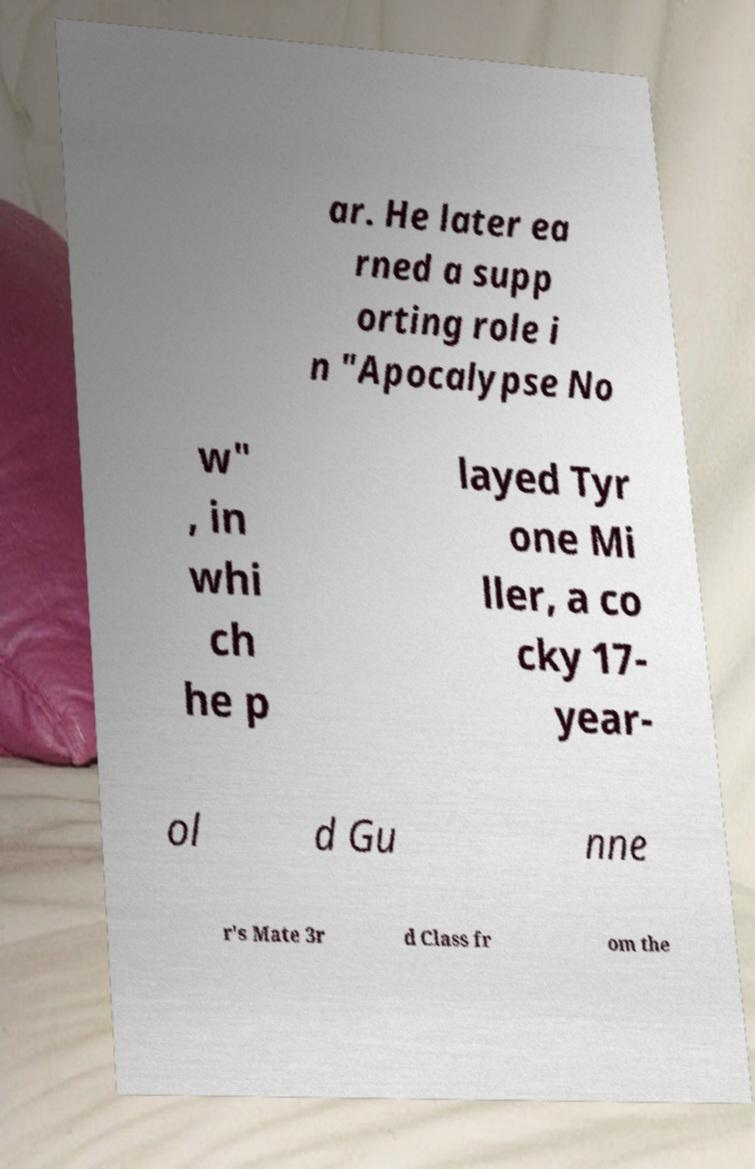Could you assist in decoding the text presented in this image and type it out clearly? ar. He later ea rned a supp orting role i n "Apocalypse No w" , in whi ch he p layed Tyr one Mi ller, a co cky 17- year- ol d Gu nne r's Mate 3r d Class fr om the 